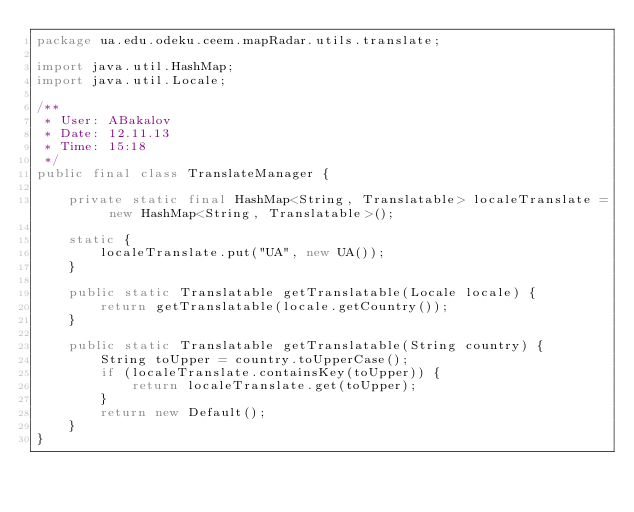<code> <loc_0><loc_0><loc_500><loc_500><_Java_>package ua.edu.odeku.ceem.mapRadar.utils.translate;

import java.util.HashMap;
import java.util.Locale;

/**
 * User: ABakalov
 * Date: 12.11.13
 * Time: 15:18
 */
public final class TranslateManager {

    private static final HashMap<String, Translatable> localeTranslate = new HashMap<String, Translatable>();

    static {
        localeTranslate.put("UA", new UA());
    }

    public static Translatable getTranslatable(Locale locale) {
        return getTranslatable(locale.getCountry());
    }

    public static Translatable getTranslatable(String country) {
        String toUpper = country.toUpperCase();
        if (localeTranslate.containsKey(toUpper)) {
            return localeTranslate.get(toUpper);
        }
        return new Default();
    }
}
</code> 